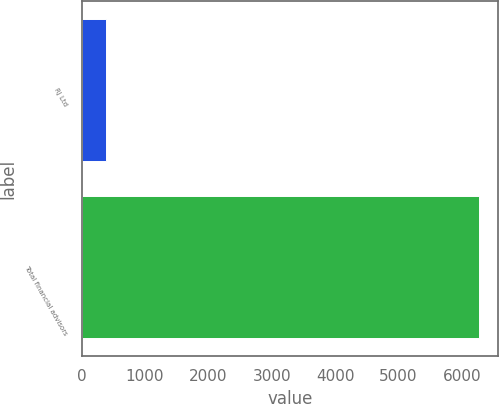Convert chart. <chart><loc_0><loc_0><loc_500><loc_500><bar_chart><fcel>RJ Ltd<fcel>Total financial advisors<nl><fcel>391<fcel>6265<nl></chart> 